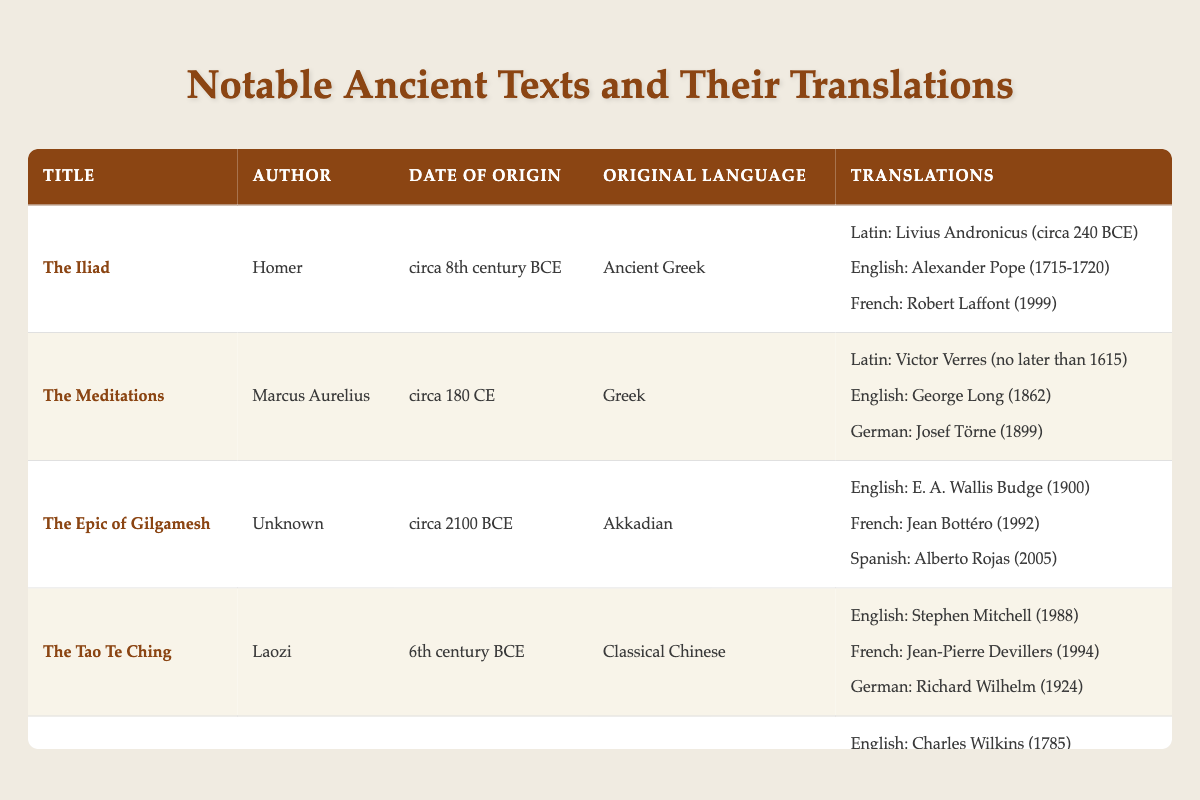What is the original language of The Bhagavad Gita? The table lists The Bhagavad Gita under the original language column, showing Sanskrit as its original language.
Answer: Sanskrit Who translated The Epic of Gilgamesh into French? According to the table, the French translation of The Epic of Gilgamesh was done by Jean Bottéro.
Answer: Jean Bottéro In what year was The Iliad first translated into Latin? The table indicates that The Iliad was first translated into Latin by Livius Andronicus around 240 BCE.
Answer: circa 240 BCE How many translations are listed for The Tao Te Ching? The table details that The Tao Te Ching has three translations listed: into English, French, and German. Therefore, there are three translations total.
Answer: 3 Which author has their work translated into Spanish? From the table, The Epic of Gilgamesh is the only work listed that has a Spanish translation, which is by Alberto Rojas.
Answer: Alberto Rojas Is there an English translation of The Meditations? Yes, the table confirms that The Meditations is translated into English by George Long in 1862.
Answer: Yes Which text has the earliest translation listed? By looking at the dates in the translations, The Iliad has a Latin translation by Livius Andronicus circa 240 BCE, which is earlier than any other translation listed in the table.
Answer: The Iliad What is the average year of translation for the English versions of the notable texts? The English translations listed have the years 1715-1720 (for The Iliad), 1862 (for The Meditations), 1900 (for The Epic of Gilgamesh), 1988 (for The Tao Te Ching), and 1785 (for The Bhagavad Gita). The average year can be calculated as follows: (1715 + 1716 + 1717 + 1718 + 1719 + 1862 + 1900 + 1785 + 1988) / 9 = 1861. The average year of English translations is therefore 1861.
Answer: 1861 What languages did The Bhagavad Gita get translated into? The table shows that The Bhagavad Gita has translations into English, German, and Latin.
Answer: English, German, Latin 